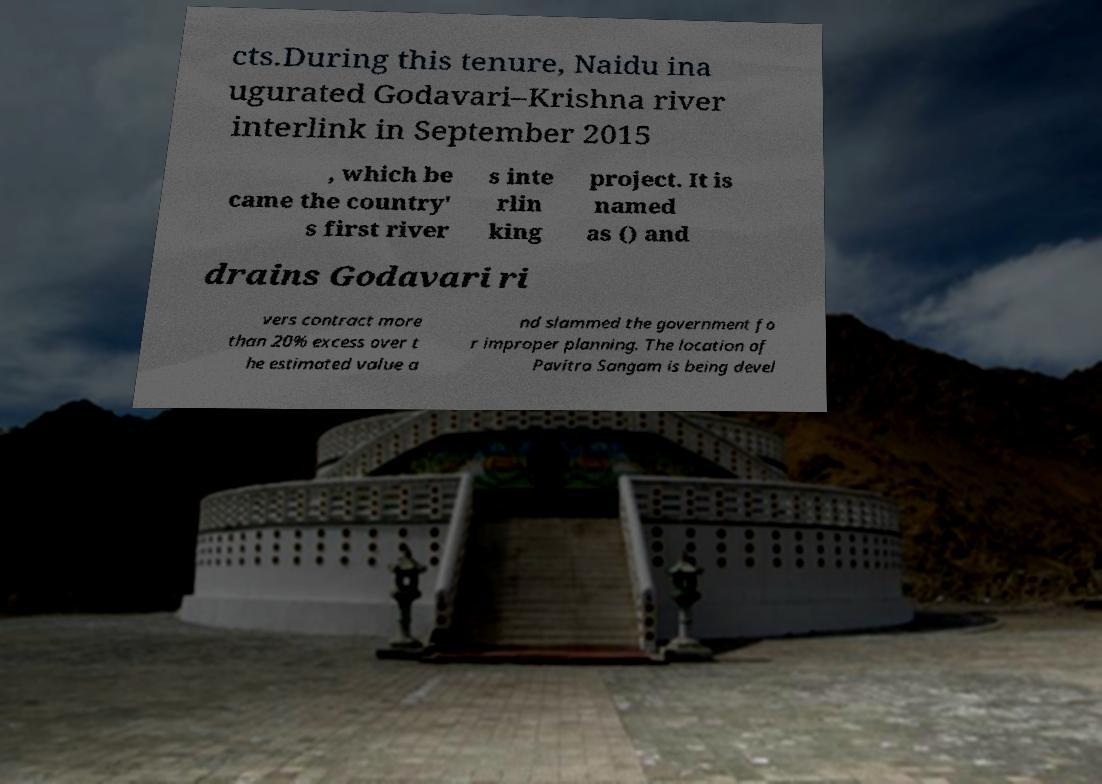For documentation purposes, I need the text within this image transcribed. Could you provide that? cts.During this tenure, Naidu ina ugurated Godavari–Krishna river interlink in September 2015 , which be came the country' s first river s inte rlin king project. It is named as () and drains Godavari ri vers contract more than 20% excess over t he estimated value a nd slammed the government fo r improper planning. The location of Pavitra Sangam is being devel 